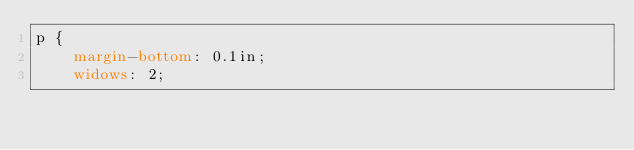Convert code to text. <code><loc_0><loc_0><loc_500><loc_500><_CSS_>p {
    margin-bottom: 0.1in;
    widows: 2;</code> 